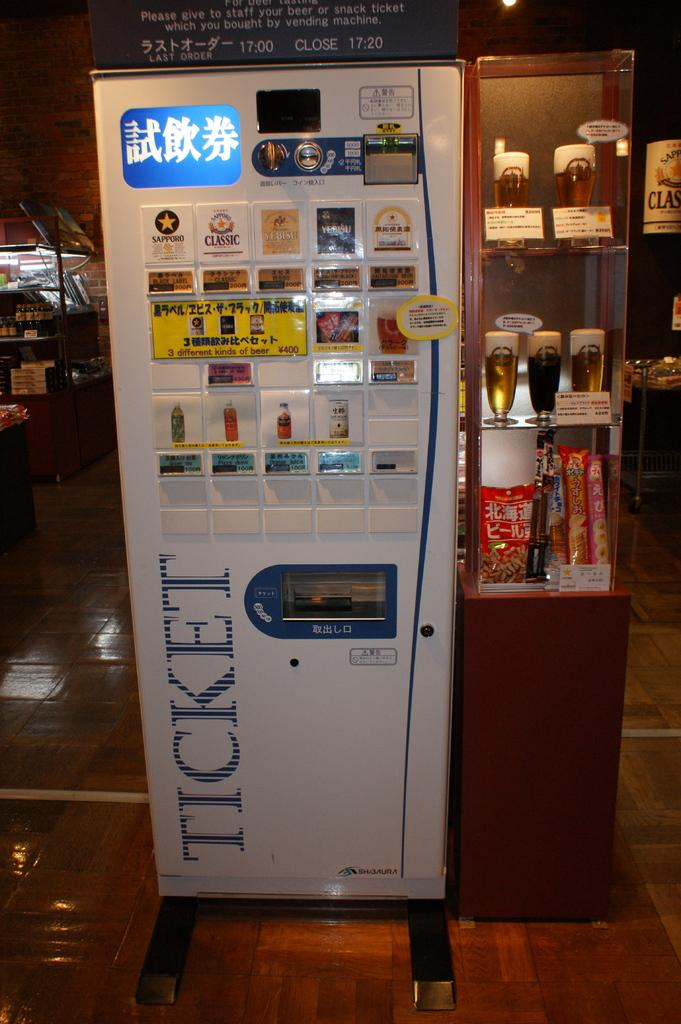<image>
Give a short and clear explanation of the subsequent image. A machine with foreign text on it and the word "ticket". 